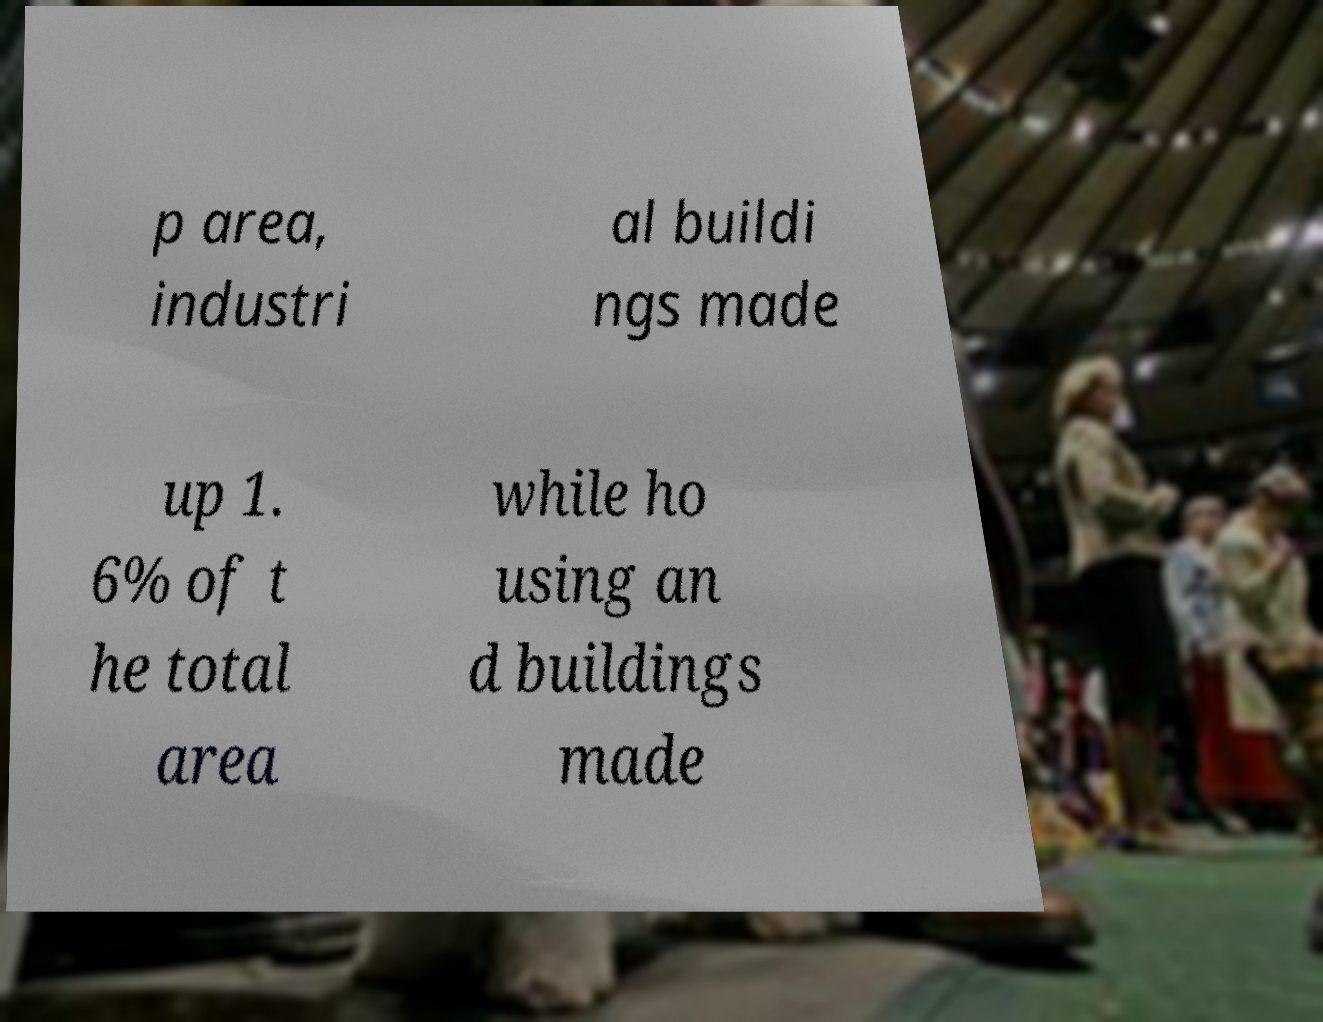For documentation purposes, I need the text within this image transcribed. Could you provide that? p area, industri al buildi ngs made up 1. 6% of t he total area while ho using an d buildings made 